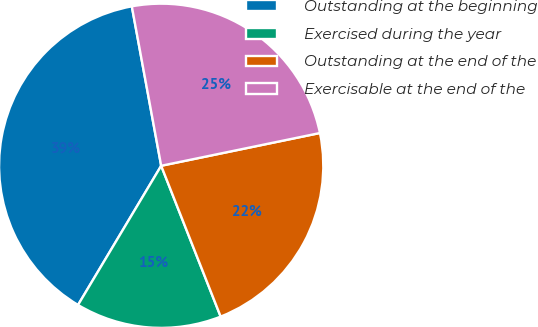Convert chart. <chart><loc_0><loc_0><loc_500><loc_500><pie_chart><fcel>Outstanding at the beginning<fcel>Exercised during the year<fcel>Outstanding at the end of the<fcel>Exercisable at the end of the<nl><fcel>38.53%<fcel>14.55%<fcel>22.26%<fcel>24.66%<nl></chart> 